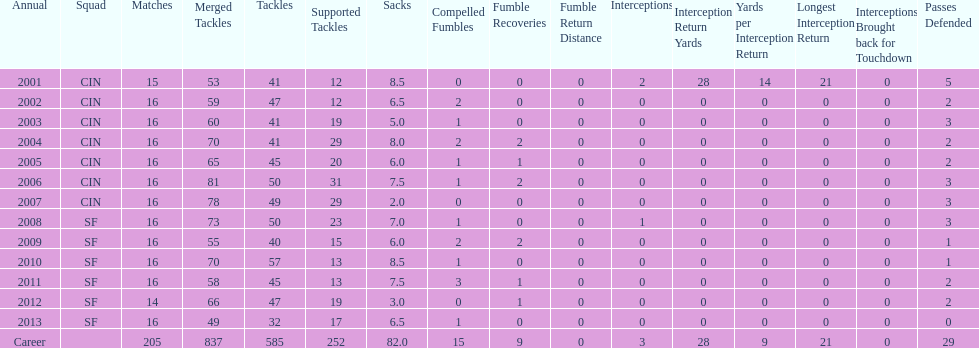How many fumble recoveries did this player have in 2004? 2. 